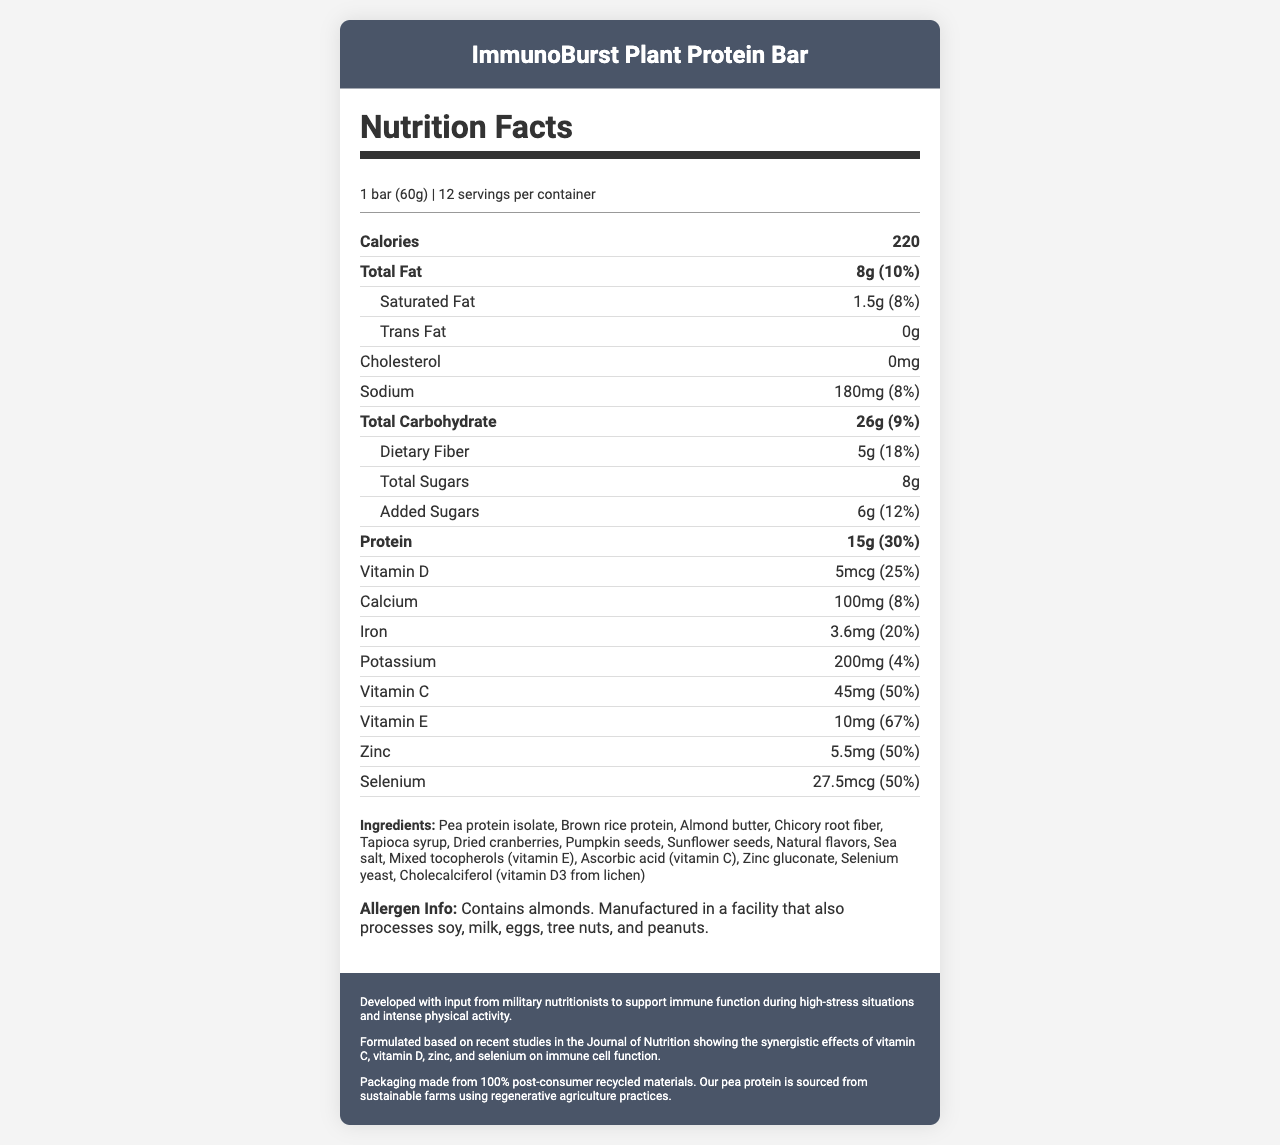what is the total fat content per serving? The total fat content is clearly listed as "Total Fat: 8g" in the nutrition facts section.
Answer: 8g how much dietary fiber does one bar contain? The bar contains 5g of dietary fiber as shown in the nutrient row for Dietary Fiber.
Answer: 5g is this product suitable for someone with a peanut allergy? The allergen info states that the product contains almonds and is manufactured in a facility that processes peanuts and other allergens.
Answer: No what is the main source of protein in the bar? The main source of protein is listed in the ingredients as "Pea protein isolate."
Answer: Pea protein isolate how many servings are there in one container? The document specifies that there are "12 servings per container."
Answer: 12 which of the following vitamins has the highest daily value percentage? A. Vitamin C B. Vitamin D C. Vitamin E D. Zinc Vitamin E has a daily value of 67%, which is higher than Vitamin C (50%), Vitamin D (25%), and Zinc (50%).
Answer: C. Vitamin E how many grams of added sugars are in one bar? A. 5g B. 6g C. 7g D. 8g The label indicates that there are 6g of added sugars.
Answer: B. 6g does the bar contain any trans fats? The document clearly states "Trans Fat: 0g."
Answer: No What are the potential allergens present in this product? The allergen info section specifies the presence of almonds and possible contamination from soy, milk, eggs, tree nuts, and peanuts.
Answer: Almonds, possibly soy, milk, eggs, tree nuts, and peanuts describe the main idea of this document. The document covers the nutrient composition, ingredient list, allergen details, and additional context regarding military input and sustainable practices.
Answer: This document provides the nutrition facts for ImmunoBurst Plant Protein Bar, emphasizing its immune-supporting vitamins and minerals, ingredients, allergen information, and notes on military relevance and sustainability. how much potassium does one bar provide? The nutrient row for potassium lists the amount as 200mg.
Answer: 200mg what inspired the formulation of this product? The footer of the document mentions that the product was formulated based on recent studies in the Journal of Nutrition.
Answer: Recent studies in the Journal of Nutrition what is the percentage of daily value for protein in one bar? The nutrient row for protein lists the daily value as 30%.
Answer: 30% which of the following ingredients is not in the bar? A. Pea protein isolate B. Whey protein C. Almond butter D. Chicory root fiber The ingredient list includes pea protein isolate, almond butter, and chicory root fiber but not whey protein.
Answer: B. Whey protein why might this product be beneficial during high-stress situations? The document mentions that the bar was developed to support immune function during high-stress situations, particularly with vitamins and minerals like Vitamin C, D, E, zinc, and selenium.
Answer: It supports immune function with added vitamins and minerals how are the packaging materials for this bar sourced? The sustainability note at the footer mentions that the packaging is made from 100% post-consumer recycled materials.
Answer: From 100% post-consumer recycled materials what is the research insight behind this product? The footer explains that the product is formulated based on studies showing the synergistic effects of these vitamins and minerals on immune cell function.
Answer: Synergistic effects of vitamin C, vitamin D, zinc, and selenium on immune cell function how many calories are there in one serving? The document lists the calorie count as 220 per serving.
Answer: 220 what is the primary source of Vitamin D in the bar? The ingredient list specifies that Vitamin D is sourced from cholecalciferol (vitamin D3 from lichen).
Answer: Cholecalciferol (vitamin D3 from lichen) is selenium a mineral present in this bar? The nutrient row lists selenium as a mineral present in the bar, with a daily value of 50%.
Answer: Yes how many grams of total carbohydrates are in the bar? The total carbohydrate content is listed as 26g in the document.
Answer: 26g does the bar contain any cholesterol? The document states "Cholesterol: 0mg."
Answer: No how much vitamin C does one bar provide? According to the nutrient row, the bar provides 45mg of Vitamin C.
Answer: 45mg what is the primary source of Vitamin E in the bar? The ingredient list includes mixed tocopherols, which is the primary source of Vitamin E.
Answer: Mixed tocopherols are there any studies directly linked to the military in developing this product? The document mentions input from military nutritionists but does not provide specific studies directly linked to the military.
Answer: Cannot be determined what is the daily value percentage for zinc in one serving? The nutrient row for zinc lists the daily value as 50%.
Answer: 50% what is the sugar content of the product? The document specifies total sugars as 8g, with 6g being added sugars.
Answer: 8g total sugars 